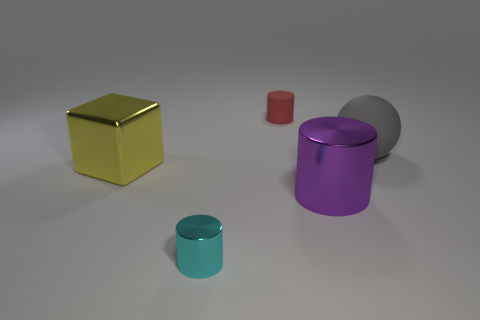Are there fewer large gray balls that are on the right side of the purple cylinder than large yellow metallic objects right of the small metallic object?
Your answer should be compact. No. How many other objects are there of the same material as the tiny red thing?
Offer a very short reply. 1. Is the material of the large ball the same as the big yellow object?
Provide a succinct answer. No. What number of other objects are there of the same size as the cyan object?
Make the answer very short. 1. How big is the purple shiny cylinder right of the small thing that is behind the block?
Your response must be concise. Large. There is a tiny cylinder in front of the big shiny thing on the left side of the metallic object in front of the big cylinder; what is its color?
Your answer should be very brief. Cyan. There is a object that is behind the purple metallic thing and right of the tiny matte cylinder; how big is it?
Offer a terse response. Large. What number of other things are there of the same shape as the small cyan thing?
Make the answer very short. 2. How many cubes are big metallic objects or large gray things?
Your answer should be compact. 1. Is there a ball that is behind the tiny object that is behind the metallic cylinder that is to the left of the purple cylinder?
Offer a terse response. No. 